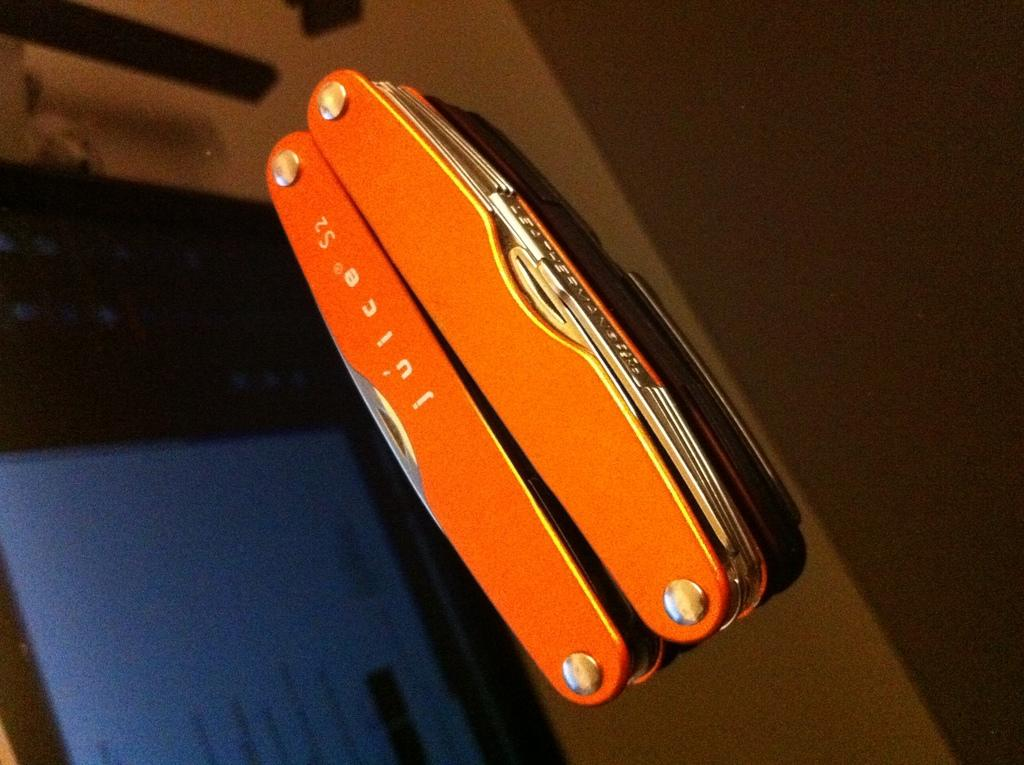What is located in the center of the image? There are objects in the center of the image. What type of screen can be seen in the background of the image? There is a digital screen in the background of the image. Can you describe any other objects visible in the background? There are other unspecified objects in the background of the image. How many ladybugs are on the boat in the image? There is no boat or ladybugs present in the image. 